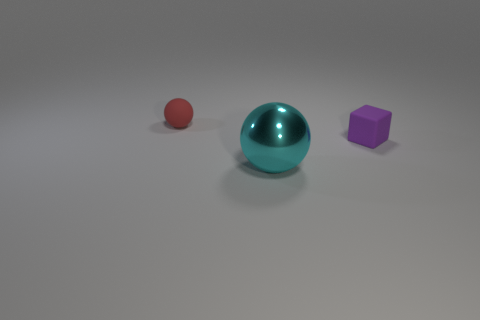There is a thing that is on the left side of the big sphere; are there any purple matte cubes in front of it?
Offer a terse response. Yes. There is a tiny object in front of the rubber object that is behind the matte cube; are there any shiny things that are on the left side of it?
Your answer should be very brief. Yes. Do the object that is on the left side of the big cyan metal ball and the small rubber object that is right of the red matte sphere have the same shape?
Your answer should be very brief. No. What color is the other object that is the same material as the tiny purple object?
Provide a succinct answer. Red. Is the number of cyan objects behind the small purple thing less than the number of cyan metallic balls?
Offer a very short reply. Yes. What is the size of the shiny object that is on the right side of the rubber thing that is behind the rubber thing to the right of the shiny ball?
Provide a succinct answer. Large. Is the object that is to the right of the big cyan metal ball made of the same material as the red thing?
Your answer should be compact. Yes. Are there any other things that have the same shape as the large cyan thing?
Your answer should be very brief. Yes. What number of objects are large purple matte cylinders or small matte things?
Your response must be concise. 2. The other object that is the same shape as the tiny red rubber object is what size?
Provide a short and direct response. Large. 